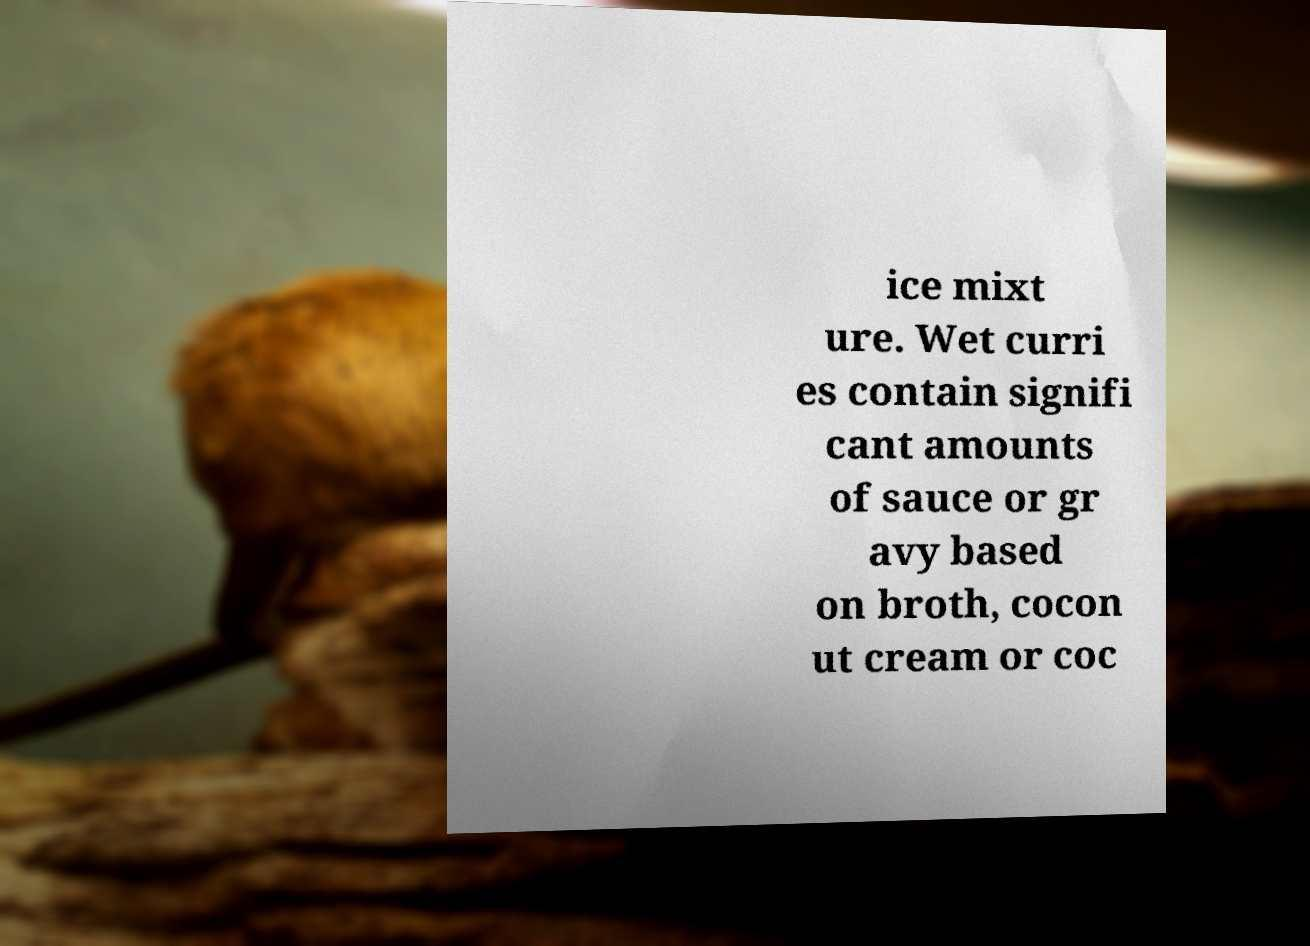Please read and relay the text visible in this image. What does it say? ice mixt ure. Wet curri es contain signifi cant amounts of sauce or gr avy based on broth, cocon ut cream or coc 